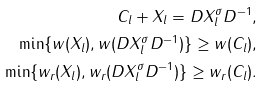Convert formula to latex. <formula><loc_0><loc_0><loc_500><loc_500>C _ { l } + X _ { l } = D X _ { l } ^ { \sigma } D ^ { - 1 } , \\ \min \{ w ( X _ { l } ) , w ( D X _ { l } ^ { \sigma } D ^ { - 1 } ) \} \geq w ( C _ { l } ) , \\ \min \{ w _ { r } ( X _ { l } ) , w _ { r } ( D X _ { l } ^ { \sigma } D ^ { - 1 } ) \} \geq w _ { r } ( C _ { l } ) .</formula> 